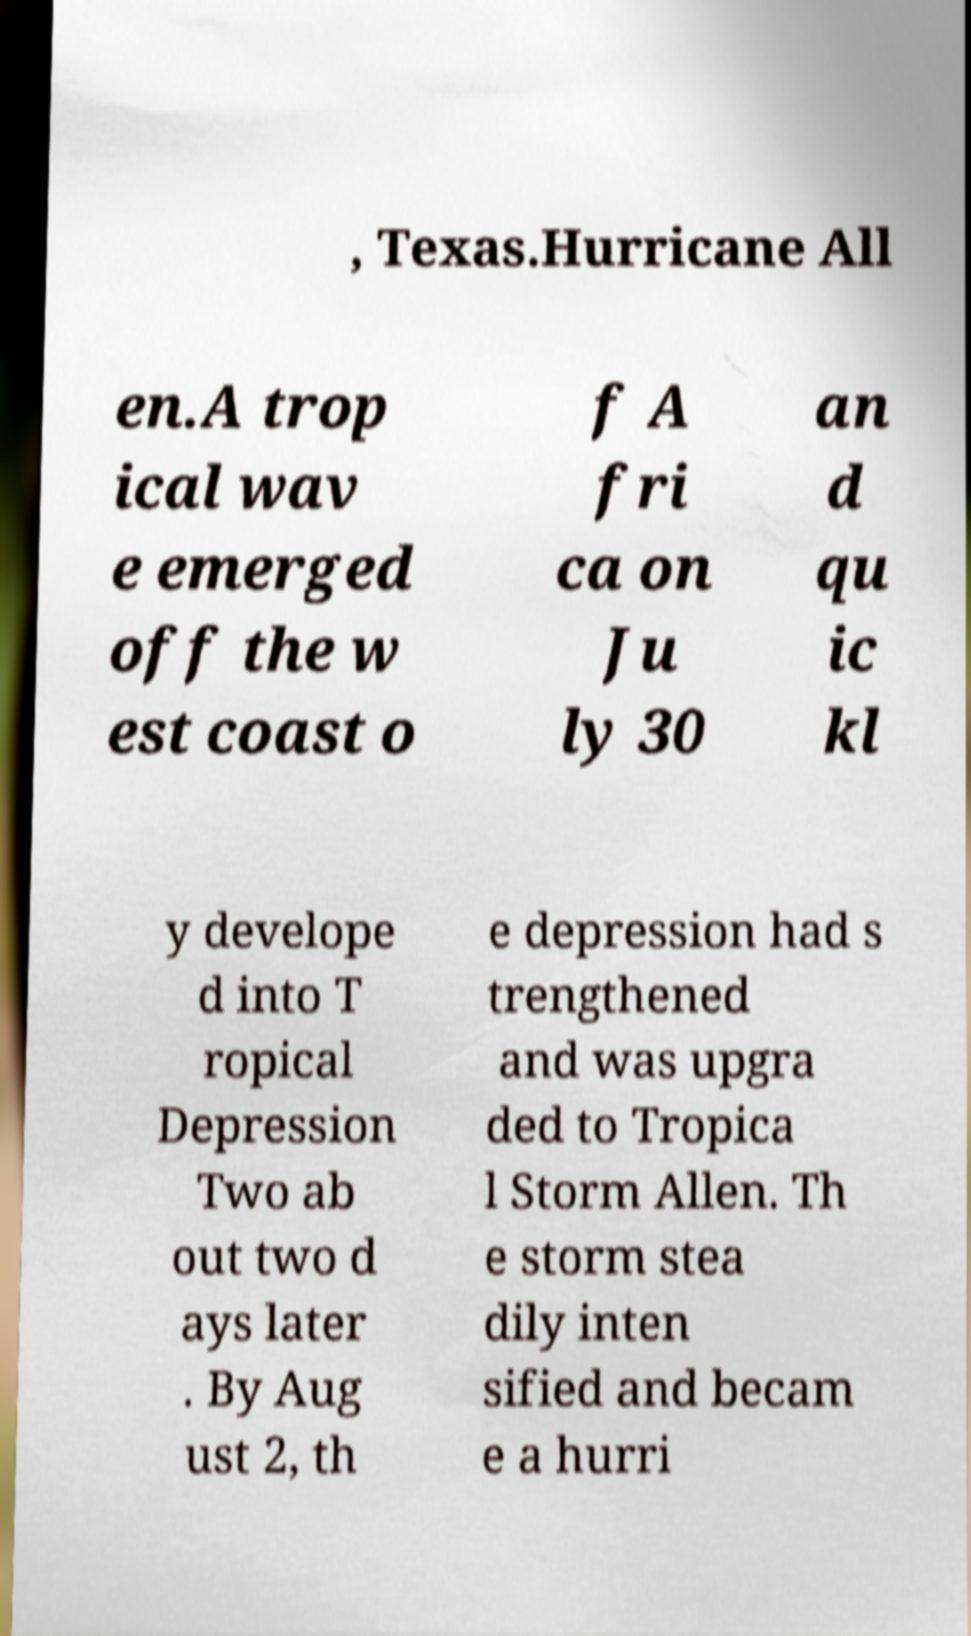What messages or text are displayed in this image? I need them in a readable, typed format. , Texas.Hurricane All en.A trop ical wav e emerged off the w est coast o f A fri ca on Ju ly 30 an d qu ic kl y develope d into T ropical Depression Two ab out two d ays later . By Aug ust 2, th e depression had s trengthened and was upgra ded to Tropica l Storm Allen. Th e storm stea dily inten sified and becam e a hurri 